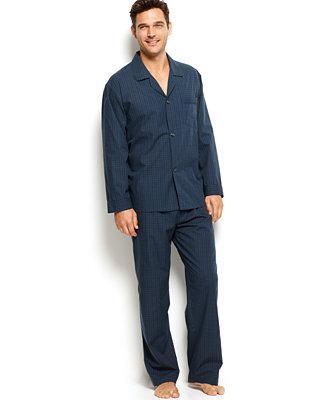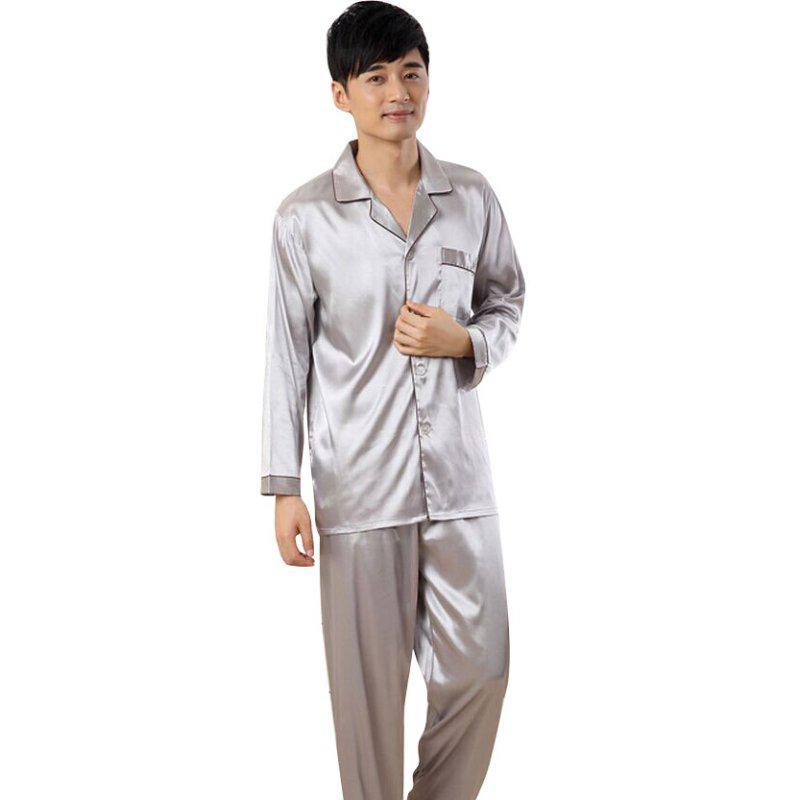The first image is the image on the left, the second image is the image on the right. Examine the images to the left and right. Is the description "in one of the images, a man is holding on to the front of his clothing with one hand" accurate? Answer yes or no. Yes. The first image is the image on the left, the second image is the image on the right. Given the left and right images, does the statement "the mans feet can be seen in the right pic" hold true? Answer yes or no. No. 